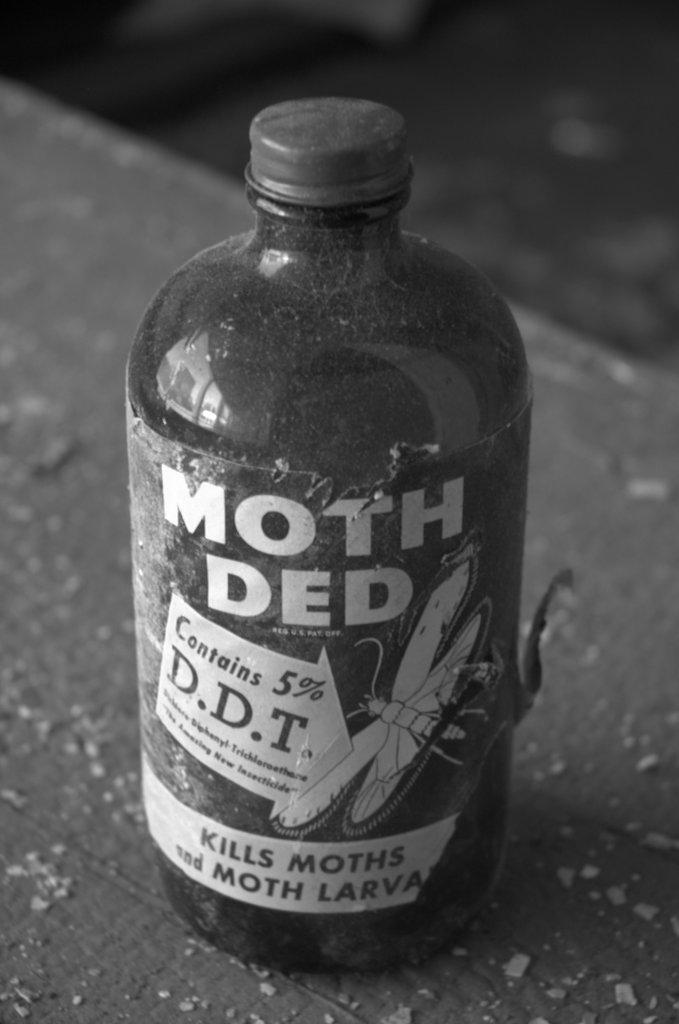<image>
Summarize the visual content of the image. A dusty bottle of moth killer that contains 5% D.D.T. 